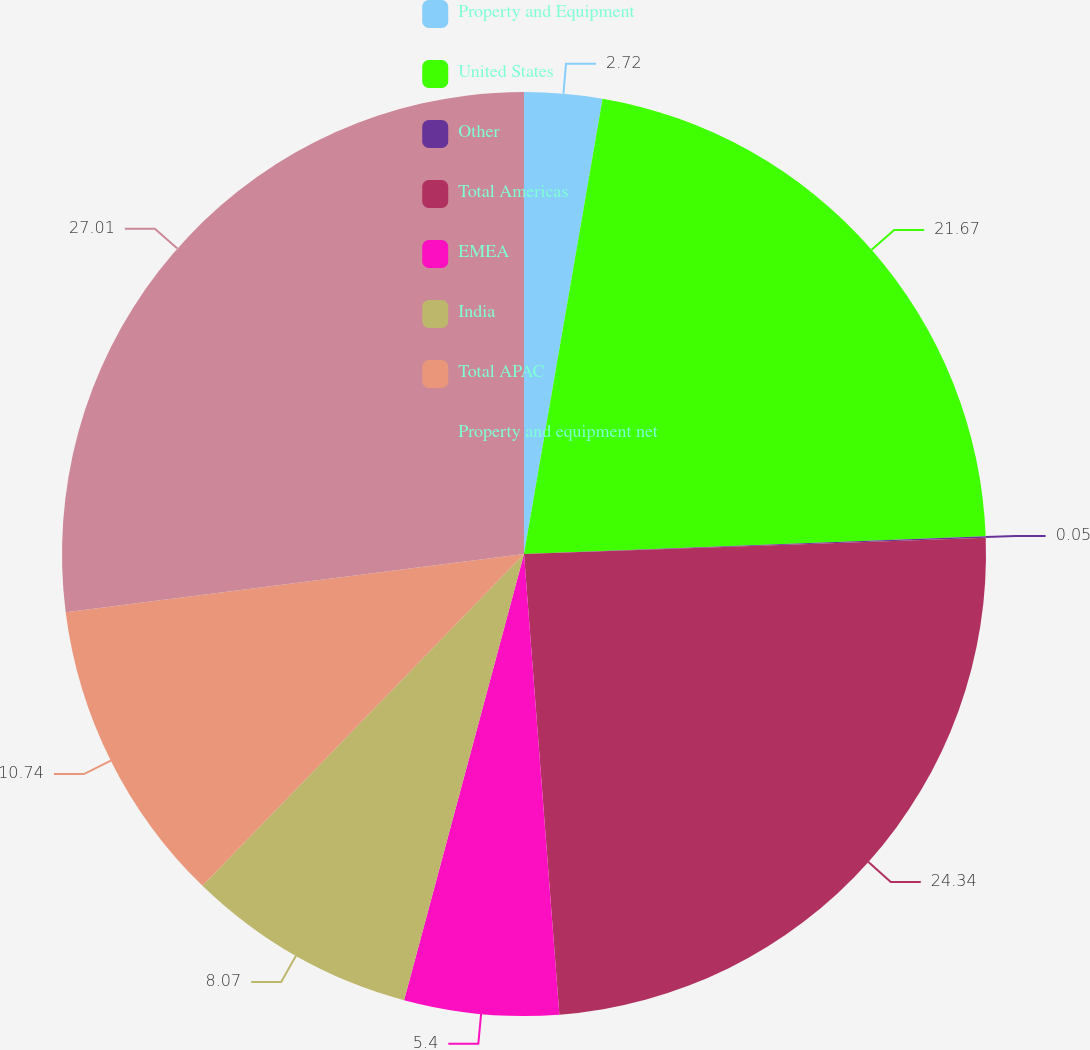<chart> <loc_0><loc_0><loc_500><loc_500><pie_chart><fcel>Property and Equipment<fcel>United States<fcel>Other<fcel>Total Americas<fcel>EMEA<fcel>India<fcel>Total APAC<fcel>Property and equipment net<nl><fcel>2.72%<fcel>21.67%<fcel>0.05%<fcel>24.34%<fcel>5.4%<fcel>8.07%<fcel>10.74%<fcel>27.01%<nl></chart> 